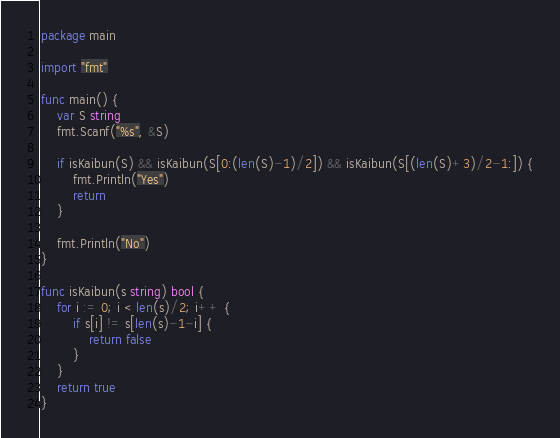Convert code to text. <code><loc_0><loc_0><loc_500><loc_500><_Go_>package main

import "fmt"

func main() {
	var S string
	fmt.Scanf("%s", &S)

	if isKaibun(S) && isKaibun(S[0:(len(S)-1)/2]) && isKaibun(S[(len(S)+3)/2-1:]) {
		fmt.Println("Yes")
		return
	}

	fmt.Println("No")
}

func isKaibun(s string) bool {
	for i := 0; i < len(s)/2; i++ {
		if s[i] != s[len(s)-1-i] {
			return false
		}
	}
	return true
}
</code> 